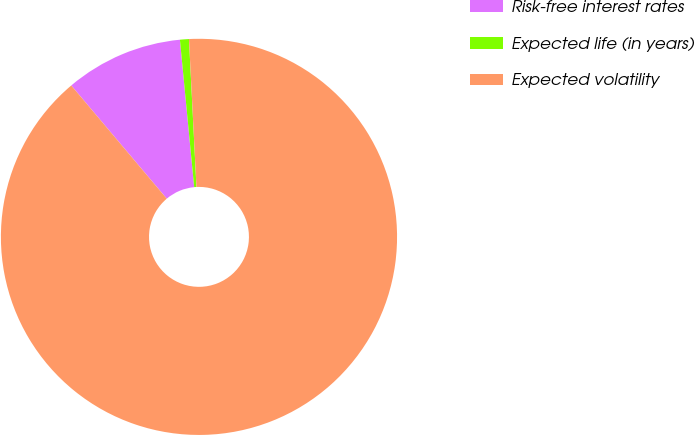<chart> <loc_0><loc_0><loc_500><loc_500><pie_chart><fcel>Risk-free interest rates<fcel>Expected life (in years)<fcel>Expected volatility<nl><fcel>9.62%<fcel>0.73%<fcel>89.65%<nl></chart> 